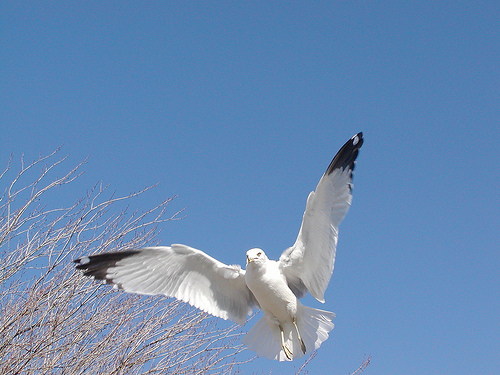<image>
Can you confirm if the bird is on the tree? No. The bird is not positioned on the tree. They may be near each other, but the bird is not supported by or resting on top of the tree. 